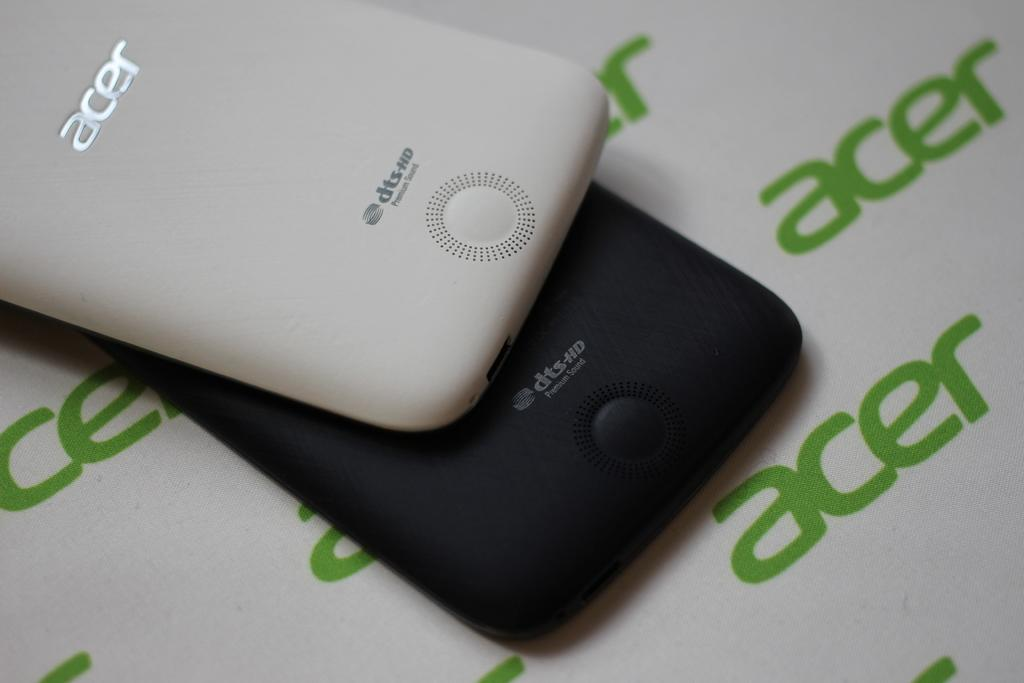<image>
Present a compact description of the photo's key features. white background with green acer logo on it and black and white acer phones that feature dts-hd premium sound 